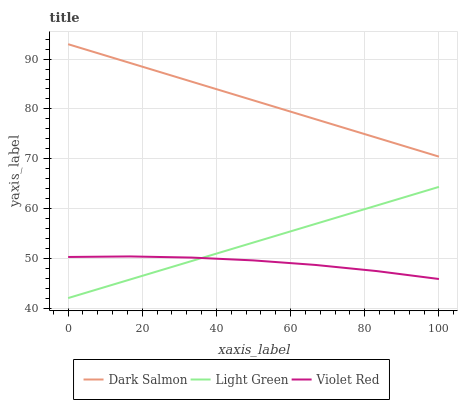Does Violet Red have the minimum area under the curve?
Answer yes or no. Yes. Does Dark Salmon have the maximum area under the curve?
Answer yes or no. Yes. Does Light Green have the minimum area under the curve?
Answer yes or no. No. Does Light Green have the maximum area under the curve?
Answer yes or no. No. Is Light Green the smoothest?
Answer yes or no. Yes. Is Violet Red the roughest?
Answer yes or no. Yes. Is Dark Salmon the smoothest?
Answer yes or no. No. Is Dark Salmon the roughest?
Answer yes or no. No. Does Light Green have the lowest value?
Answer yes or no. Yes. Does Dark Salmon have the lowest value?
Answer yes or no. No. Does Dark Salmon have the highest value?
Answer yes or no. Yes. Does Light Green have the highest value?
Answer yes or no. No. Is Violet Red less than Dark Salmon?
Answer yes or no. Yes. Is Dark Salmon greater than Light Green?
Answer yes or no. Yes. Does Light Green intersect Violet Red?
Answer yes or no. Yes. Is Light Green less than Violet Red?
Answer yes or no. No. Is Light Green greater than Violet Red?
Answer yes or no. No. Does Violet Red intersect Dark Salmon?
Answer yes or no. No. 